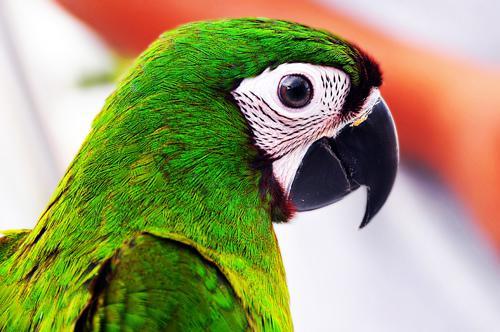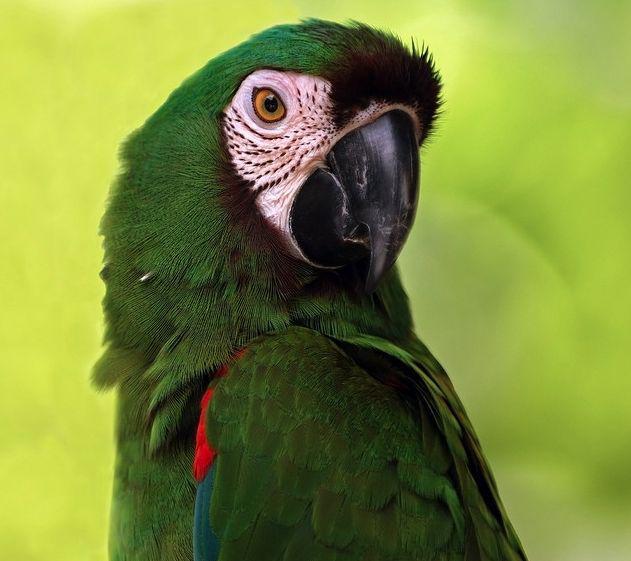The first image is the image on the left, the second image is the image on the right. Given the left and right images, does the statement "In each image, the parrot faces rightward." hold true? Answer yes or no. Yes. The first image is the image on the left, the second image is the image on the right. Evaluate the accuracy of this statement regarding the images: "The bird in the right image is using a tree branch for its perch.". Is it true? Answer yes or no. No. 